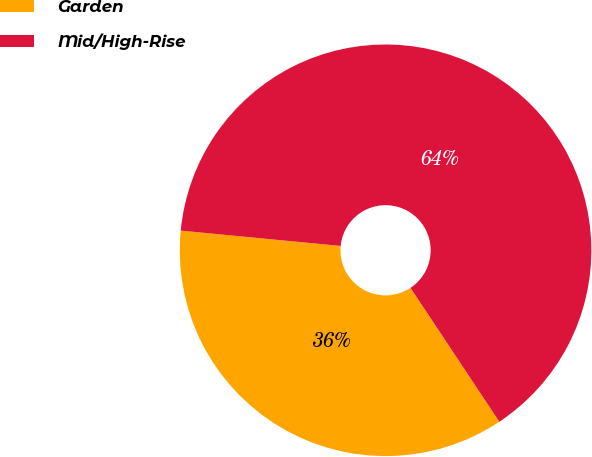<chart> <loc_0><loc_0><loc_500><loc_500><pie_chart><fcel>Garden<fcel>Mid/High-Rise<nl><fcel>35.85%<fcel>64.15%<nl></chart> 